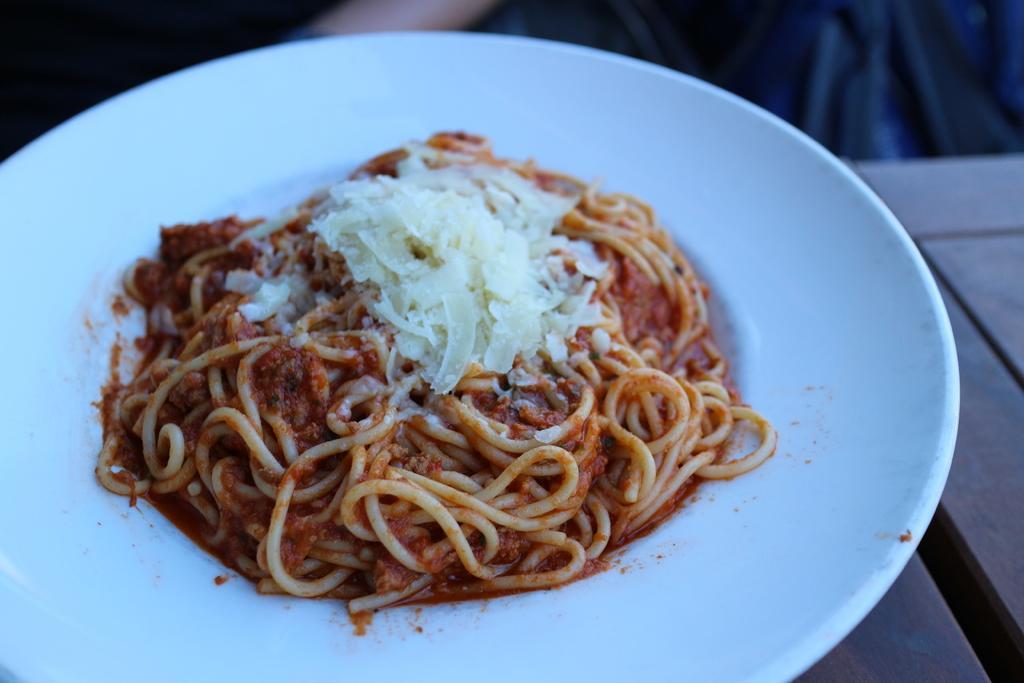Describe this image in one or two sentences. In this image I see the white plate on which I see the noodles and I see the white color thing on it and I see the brown color surface over here. 